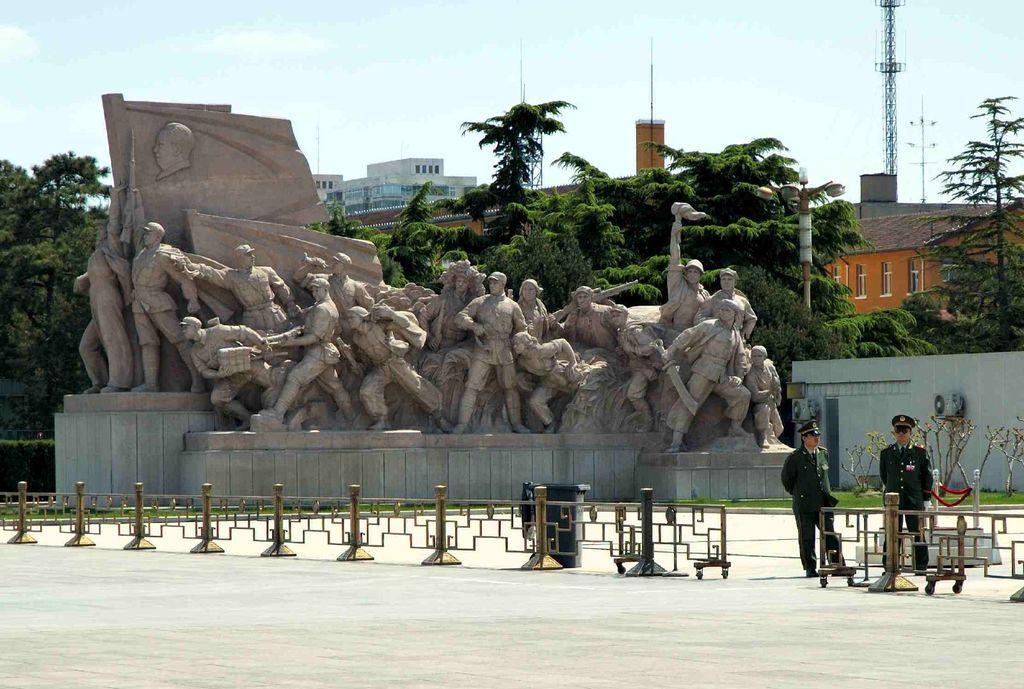In one or two sentences, can you explain what this image depicts? In the foreground of the picture I can see the statues. There are two men on the road and they are on the right side. I can see the design metal fence on the road. In the background, I can see the buildings and trees. There are clouds in the sky. It is looking like a transmission tower on the top right side of the picture. 